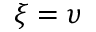Convert formula to latex. <formula><loc_0><loc_0><loc_500><loc_500>\xi = \upsilon</formula> 